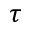Convert formula to latex. <formula><loc_0><loc_0><loc_500><loc_500>\tau</formula> 